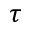Convert formula to latex. <formula><loc_0><loc_0><loc_500><loc_500>\tau</formula> 